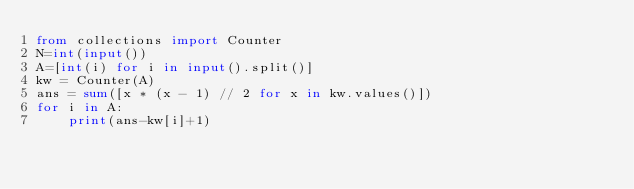<code> <loc_0><loc_0><loc_500><loc_500><_Python_>from collections import Counter
N=int(input())
A=[int(i) for i in input().split()]
kw = Counter(A)
ans = sum([x * (x - 1) // 2 for x in kw.values()])
for i in A:
    print(ans-kw[i]+1)</code> 